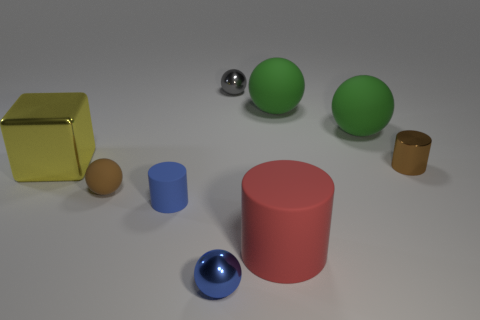Are there more tiny brown rubber objects that are to the left of the tiny brown rubber object than large yellow shiny things that are on the right side of the large red object? Upon reviewing the image, it appears that there is only one tiny brown rubber object of note, and there are no other tiny brown rubber objects to the left of it. Additionally, there is one large yellow shiny cube on the right side of the large red cylinder. Therefore, the answer is yes, as there cannot be more objects than the one, since other brown objects similar in appearance are not visible in the image. 